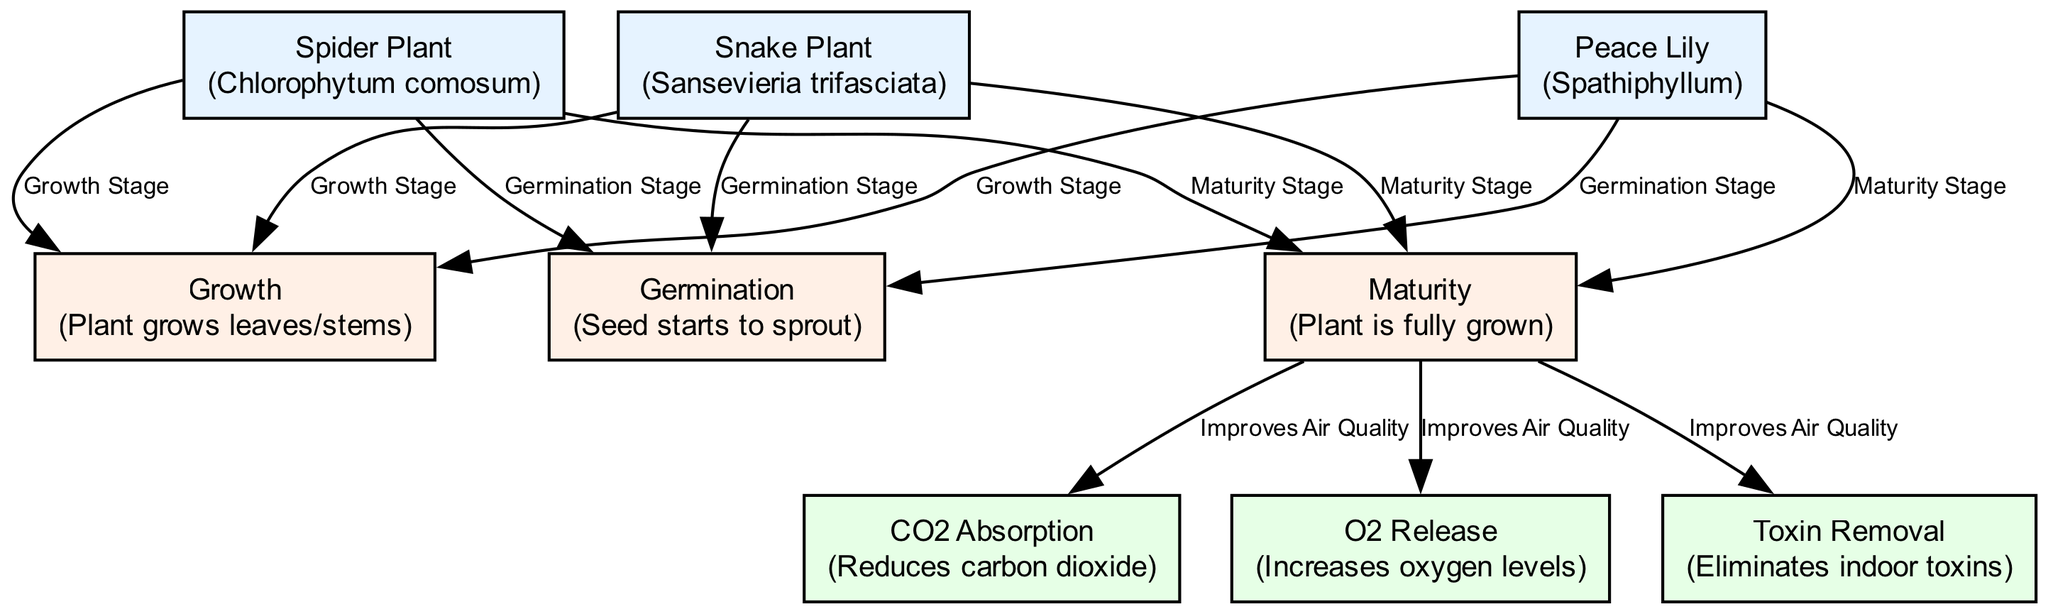What is the label of the first houseplant node? The first houseplant node in the diagram is identified as "houseplant1". By examining the node's label, we see it references "Spider Plant," which is its description.
Answer: Spider Plant How many growth cycles are represented in the diagram? The diagram contains a total of three growth cycle nodes, labeled as Germination, Growth, and Maturity. These can be counted directly from the nodes section in the diagram.
Answer: 3 Which houseplant goes through the Maturity growth stage? All three houseplants—Spider Plant, Peace Lily, and Snake Plant—are linked to the Maturity growth stage. By checking the edges connected to the maturity cycle, each houseplant can be confirmed as a contributor to that stage.
Answer: Spider Plant, Peace Lily, Snake Plant What air quality feature is improved during the Maturity stage? The Maturity stage has edges pointing towards three air quality features: CO2 Absorption, O2 Release, and Toxin Removal. Each is connected directly from the Maturity cycle node, indicating that these features are all enhanced during maturity.
Answer: CO2 Absorption, O2 Release, Toxin Removal Is there a direct relationship between the Snake Plant and CO2 Absorption? Yes, the Snake Plant undergoes the Maturity growth cycle, which, in turn, has a direct edge leading to the CO2 Absorption feature. Hence, it signifies that the Snake Plant contributes to CO2 Absorption indirectly through its growth process.
Answer: Yes Which node represents the release of oxygen? The diagram includes the air quality feature labeled "O2 Release", which specifically focuses on increasing oxygen levels within the indoor environment. This node can be pinpointed from the air quality features linked to the growth cycles.
Answer: O2 Release What is the role of the growth cycle labeled "Maturity"? The Maturity growth cycle functions as a crucial transition where the plant reaches its full growth, thereby enabling it to enhance various air quality aspects. By analyzing the connections from the Maturity stage, we understand its role in improving CO2 levels, oxygen release, and toxin removal.
Answer: Improves Air Quality How are houseplants connected to the Growth stage? Each houseplant node (Spider Plant, Peace Lily, and Snake Plant) has an edge leading to the Growth stage node. This signifies that all these plants experience this stage during their life cycle as a necessary part of their growth progression.
Answer: Spider Plant, Peace Lily, Snake Plant What does the growth cycle "Germination" indicate? The Germination cycle indicates the initial stage where seeds begin to sprout. This definition can be extracted from the node's description within the diagram, clarifying its role in the growth processes of the houseplants.
Answer: Seed starts to sprout 